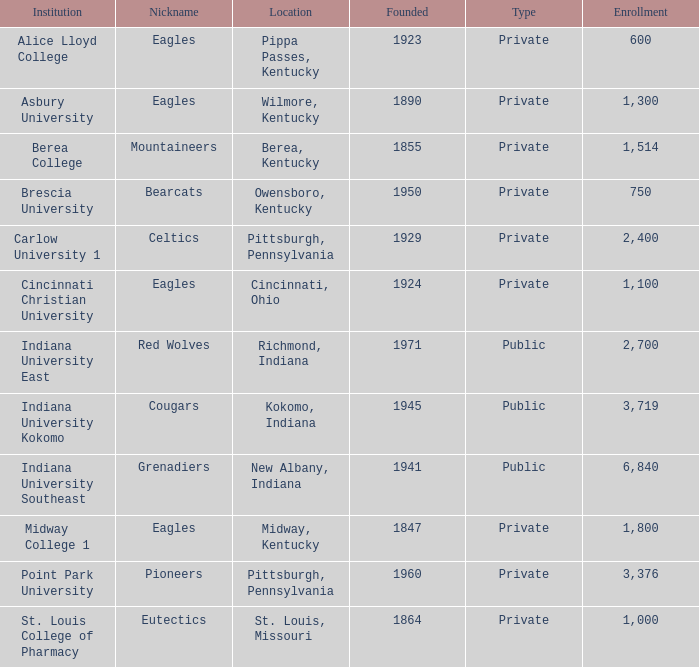Identifying the oldest private college with the mountaineers as its moniker? 1855.0. 